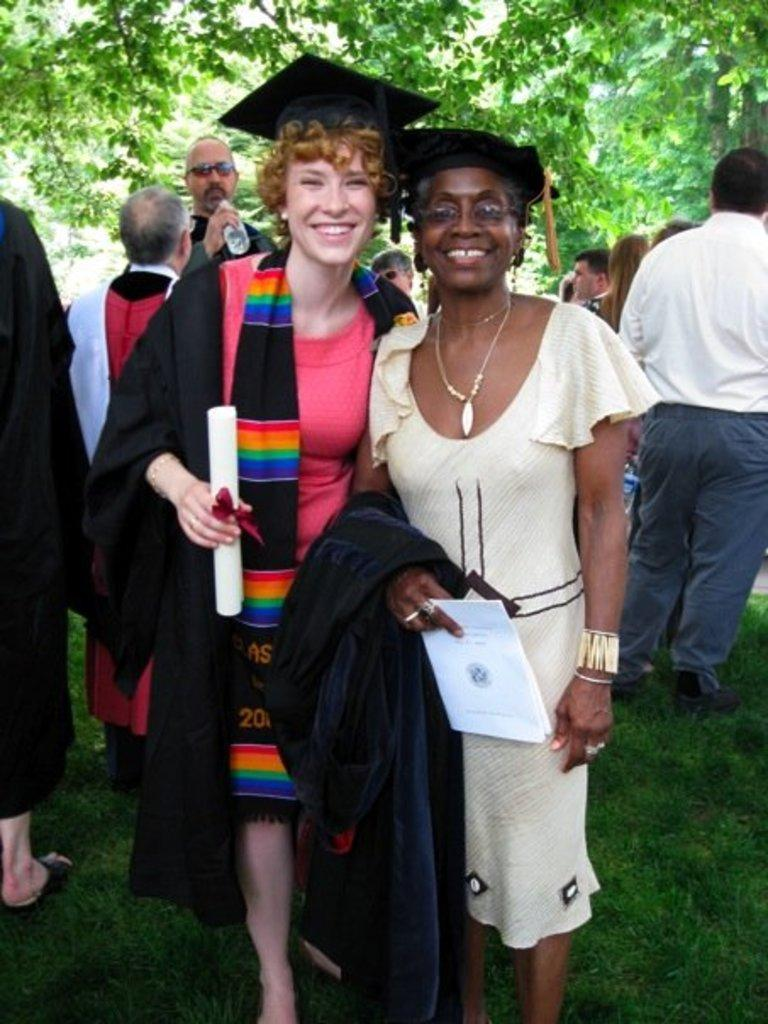How many women are in the image? There are two women standing in the middle of the image. What are the women doing in the image? The women are smiling in the image. What are the women wearing on their heads? The women are wearing black color caps. Can you describe the people in the background of the image? There are people standing at the back side of the image. What can be seen at the top of the image? Trees are visible at the top of the image. What type of paint is the woman holding in the image? There is no paint visible in the image; the women are wearing black color caps. Can you describe the locket the woman is wearing in the image? There is no locket visible in the image; the women are wearing black color caps. 